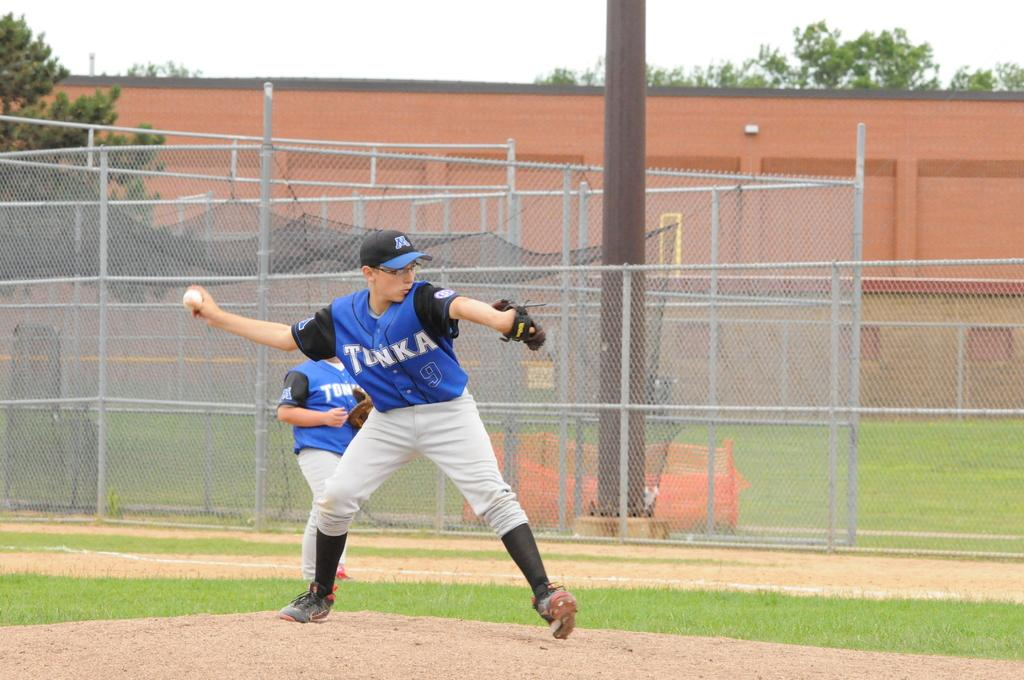<image>
Summarize the visual content of the image. two boys in blue and black jerseys with tonka on the front 